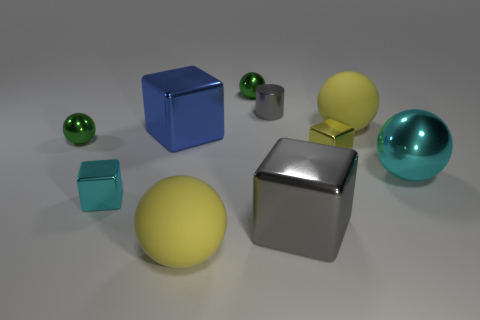The cylinder that is made of the same material as the big cyan object is what color?
Your answer should be compact. Gray. What number of rubber things are either cyan blocks or objects?
Give a very brief answer. 2. There is a blue thing that is the same size as the cyan sphere; what is its shape?
Your answer should be compact. Cube. What number of objects are yellow spheres that are behind the yellow shiny object or rubber spheres right of the tiny gray metallic cylinder?
Provide a short and direct response. 1. What is the material of the other cube that is the same size as the cyan block?
Give a very brief answer. Metal. How many other things are there of the same material as the tiny gray object?
Offer a terse response. 7. Is the number of tiny yellow blocks in front of the big gray object the same as the number of yellow rubber objects on the right side of the big cyan metal ball?
Offer a very short reply. Yes. What number of red objects are large blocks or metallic cubes?
Provide a succinct answer. 0. Do the tiny cylinder and the big metallic block to the right of the tiny gray cylinder have the same color?
Give a very brief answer. Yes. How many other objects are there of the same color as the small shiny cylinder?
Ensure brevity in your answer.  1. 